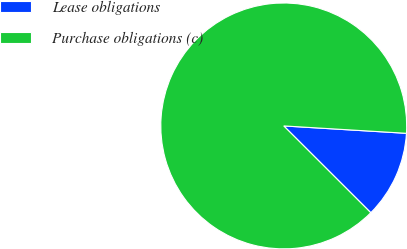Convert chart to OTSL. <chart><loc_0><loc_0><loc_500><loc_500><pie_chart><fcel>Lease obligations<fcel>Purchase obligations (c)<nl><fcel>11.52%<fcel>88.48%<nl></chart> 